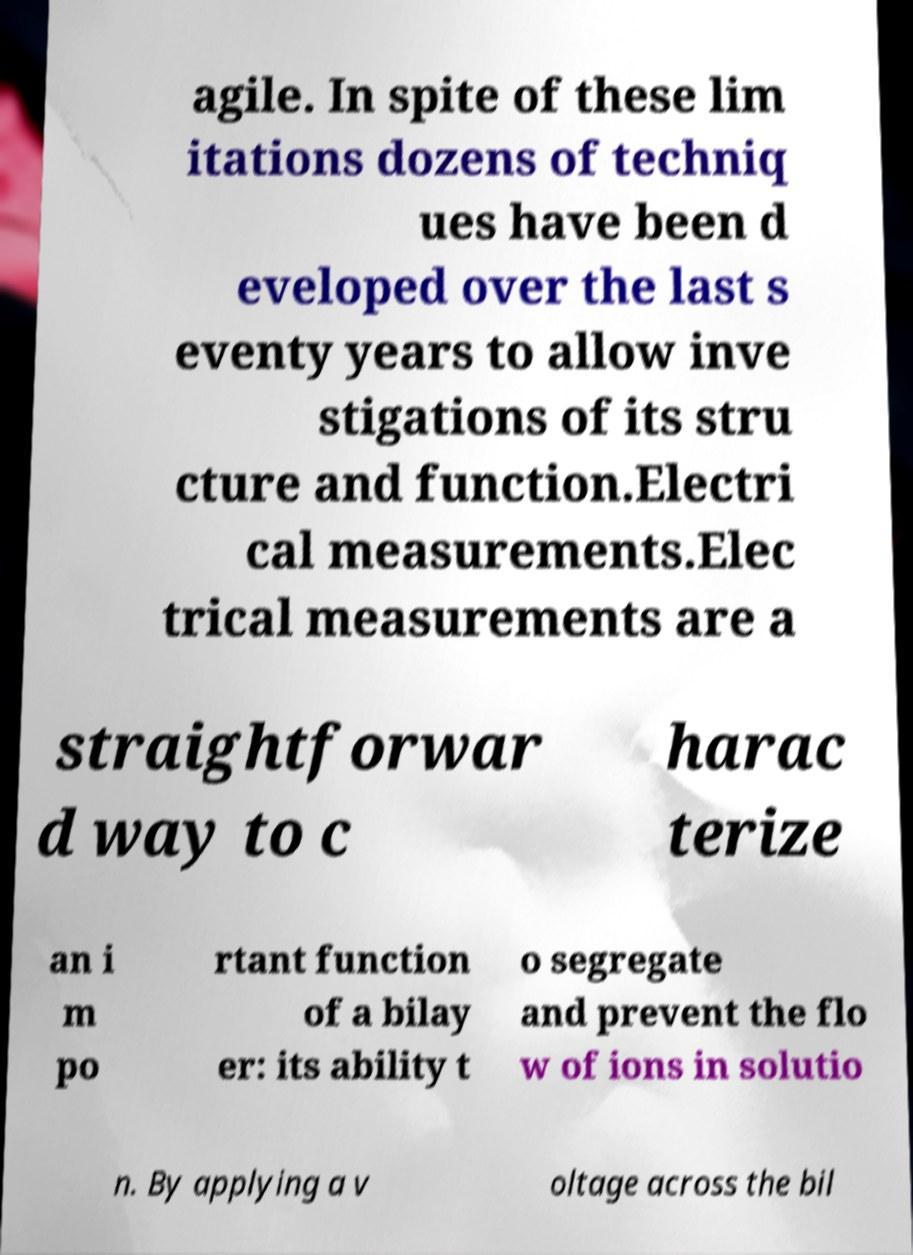Could you assist in decoding the text presented in this image and type it out clearly? agile. In spite of these lim itations dozens of techniq ues have been d eveloped over the last s eventy years to allow inve stigations of its stru cture and function.Electri cal measurements.Elec trical measurements are a straightforwar d way to c harac terize an i m po rtant function of a bilay er: its ability t o segregate and prevent the flo w of ions in solutio n. By applying a v oltage across the bil 